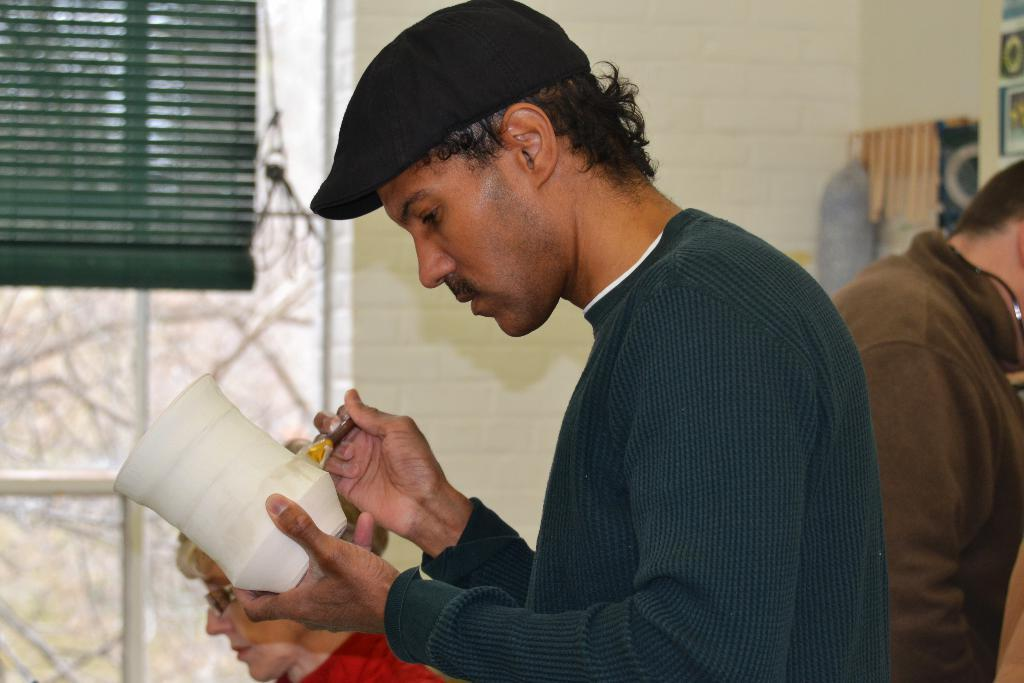What is the person in the image wearing on their head? The person is wearing a cap in the image. What is the person holding in their hand? The person is holding a brush and a pot in the image. Can you describe the background of the image? There are other people in the background of the image, as well as a window with a curtain and a wall. What type of bead is the person using to help write the caption in the image? There is no bead or caption present in the image. 